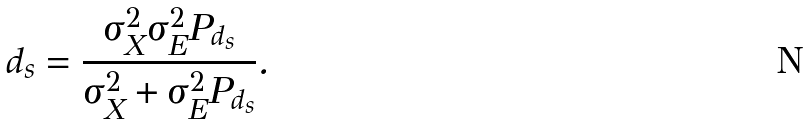Convert formula to latex. <formula><loc_0><loc_0><loc_500><loc_500>d _ { s } = \frac { \sigma _ { X } ^ { 2 } \sigma _ { E } ^ { 2 } P _ { d _ { s } } } { \sigma _ { X } ^ { 2 } + \sigma _ { E } ^ { 2 } P _ { d _ { s } } } .</formula> 